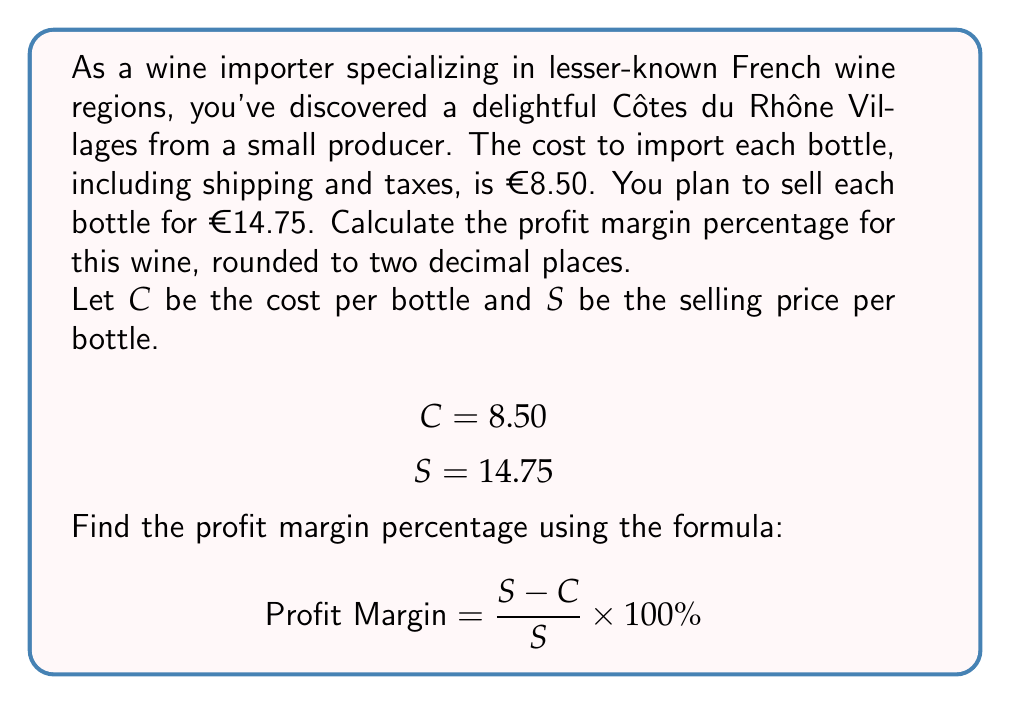Teach me how to tackle this problem. To calculate the profit margin percentage, we'll follow these steps:

1. Calculate the profit per bottle:
   $$\text{Profit} = S - C = 14.75 - 8.50 = 6.25$$

2. Use the profit margin formula:
   $$\text{Profit Margin} = \frac{S - C}{S} \times 100\%$$

3. Substitute the values:
   $$\text{Profit Margin} = \frac{14.75 - 8.50}{14.75} \times 100\%$$
   $$= \frac{6.25}{14.75} \times 100\%$$

4. Perform the division:
   $$= 0.4237288135... \times 100\%$$

5. Convert to percentage and round to two decimal places:
   $$= 42.37\%$$

This means that 42.37% of the selling price is profit.
Answer: The profit margin for importing the Côtes du Rhône Villages wine is 42.37%. 